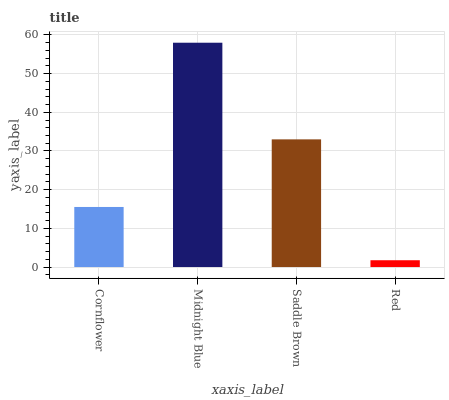Is Red the minimum?
Answer yes or no. Yes. Is Midnight Blue the maximum?
Answer yes or no. Yes. Is Saddle Brown the minimum?
Answer yes or no. No. Is Saddle Brown the maximum?
Answer yes or no. No. Is Midnight Blue greater than Saddle Brown?
Answer yes or no. Yes. Is Saddle Brown less than Midnight Blue?
Answer yes or no. Yes. Is Saddle Brown greater than Midnight Blue?
Answer yes or no. No. Is Midnight Blue less than Saddle Brown?
Answer yes or no. No. Is Saddle Brown the high median?
Answer yes or no. Yes. Is Cornflower the low median?
Answer yes or no. Yes. Is Cornflower the high median?
Answer yes or no. No. Is Saddle Brown the low median?
Answer yes or no. No. 